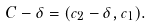Convert formula to latex. <formula><loc_0><loc_0><loc_500><loc_500>C - \delta = ( c _ { 2 } - \delta , c _ { 1 } ) .</formula> 